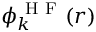<formula> <loc_0><loc_0><loc_500><loc_500>\phi _ { k } ^ { H F } ( { r } )</formula> 